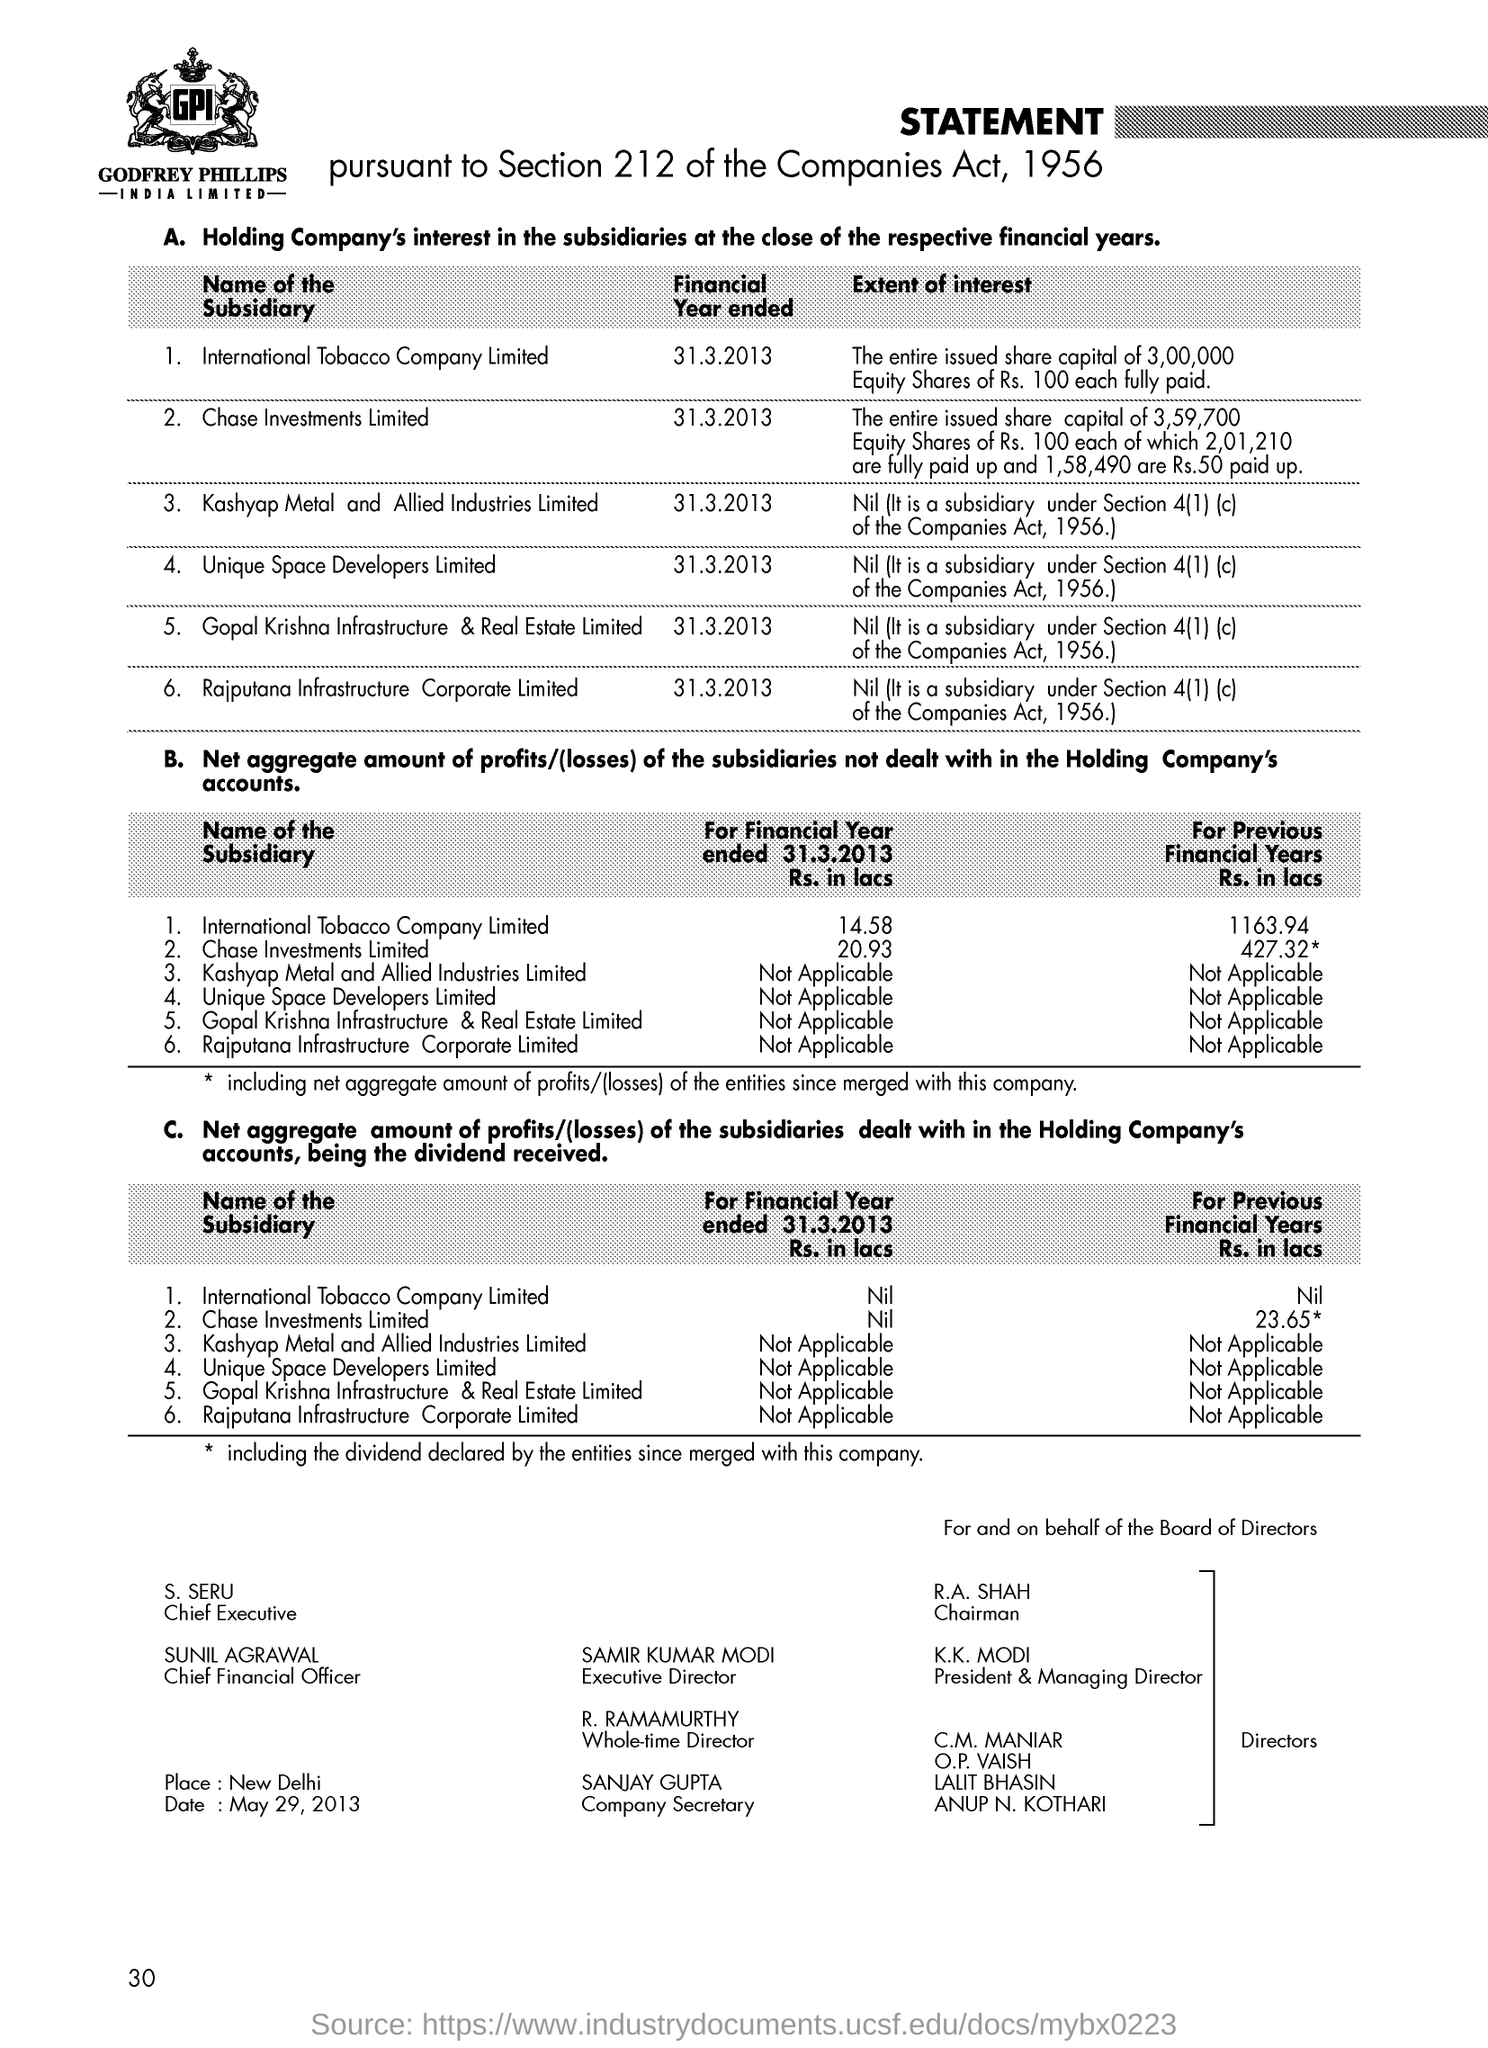What is the name of the company?
Your response must be concise. GODFREY PHILLIPS INDIA LIMITED. Who is mr. s. seru?
Your answer should be very brief. Chief executive. 